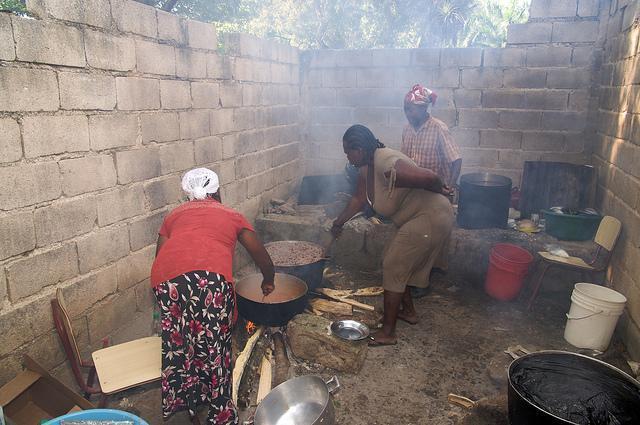What are the women doing over the large containers on the ground?
Choose the correct response, then elucidate: 'Answer: answer
Rationale: rationale.'
Options: Washing, cleaning, lighting fire, cooking. Answer: cooking.
Rationale: They are making food over the fire. 